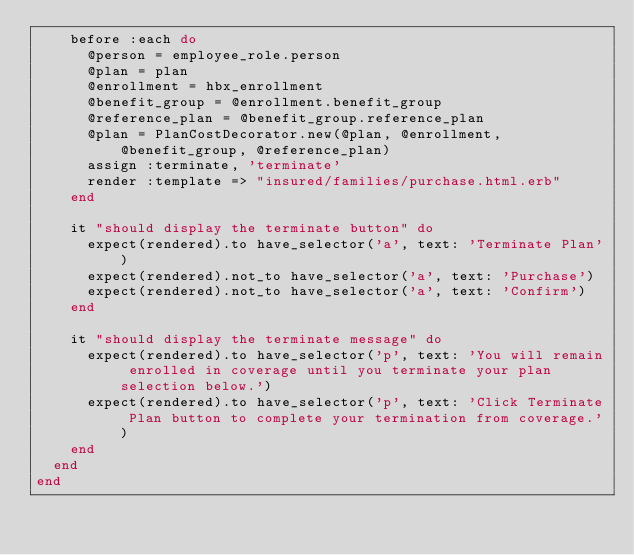<code> <loc_0><loc_0><loc_500><loc_500><_Ruby_>    before :each do
      @person = employee_role.person
      @plan = plan
      @enrollment = hbx_enrollment
      @benefit_group = @enrollment.benefit_group
      @reference_plan = @benefit_group.reference_plan
      @plan = PlanCostDecorator.new(@plan, @enrollment, @benefit_group, @reference_plan)
      assign :terminate, 'terminate'
      render :template => "insured/families/purchase.html.erb"
    end

    it "should display the terminate button" do
      expect(rendered).to have_selector('a', text: 'Terminate Plan')
      expect(rendered).not_to have_selector('a', text: 'Purchase')
      expect(rendered).not_to have_selector('a', text: 'Confirm')
    end

    it "should display the terminate message" do
      expect(rendered).to have_selector('p', text: 'You will remain enrolled in coverage until you terminate your plan selection below.')
      expect(rendered).to have_selector('p', text: 'Click Terminate Plan button to complete your termination from coverage.')
    end
  end
end
</code> 